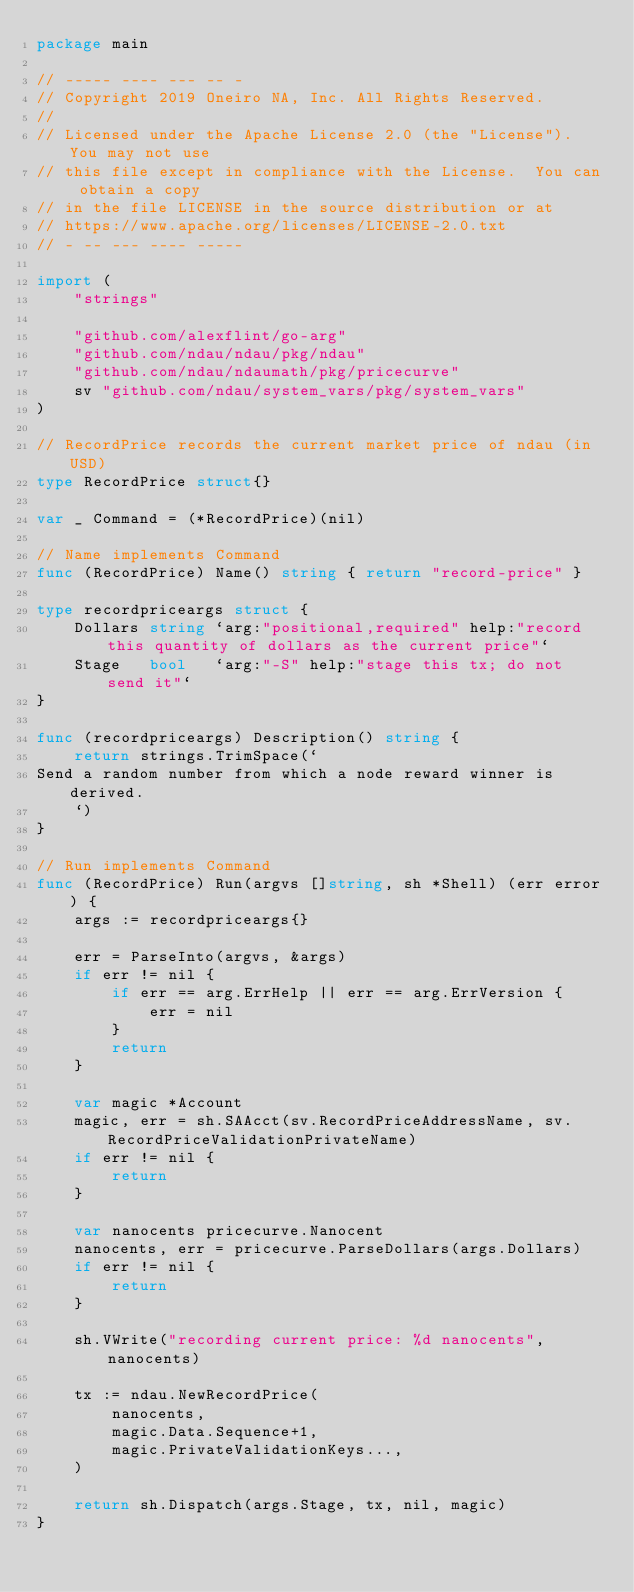Convert code to text. <code><loc_0><loc_0><loc_500><loc_500><_Go_>package main

// ----- ---- --- -- -
// Copyright 2019 Oneiro NA, Inc. All Rights Reserved.
//
// Licensed under the Apache License 2.0 (the "License").  You may not use
// this file except in compliance with the License.  You can obtain a copy
// in the file LICENSE in the source distribution or at
// https://www.apache.org/licenses/LICENSE-2.0.txt
// - -- --- ---- -----

import (
	"strings"

	"github.com/alexflint/go-arg"
	"github.com/ndau/ndau/pkg/ndau"
	"github.com/ndau/ndaumath/pkg/pricecurve"
	sv "github.com/ndau/system_vars/pkg/system_vars"
)

// RecordPrice records the current market price of ndau (in USD)
type RecordPrice struct{}

var _ Command = (*RecordPrice)(nil)

// Name implements Command
func (RecordPrice) Name() string { return "record-price" }

type recordpriceargs struct {
	Dollars string `arg:"positional,required" help:"record this quantity of dollars as the current price"`
	Stage   bool   `arg:"-S" help:"stage this tx; do not send it"`
}

func (recordpriceargs) Description() string {
	return strings.TrimSpace(`
Send a random number from which a node reward winner is derived.
	`)
}

// Run implements Command
func (RecordPrice) Run(argvs []string, sh *Shell) (err error) {
	args := recordpriceargs{}

	err = ParseInto(argvs, &args)
	if err != nil {
		if err == arg.ErrHelp || err == arg.ErrVersion {
			err = nil
		}
		return
	}

	var magic *Account
	magic, err = sh.SAAcct(sv.RecordPriceAddressName, sv.RecordPriceValidationPrivateName)
	if err != nil {
		return
	}

	var nanocents pricecurve.Nanocent
	nanocents, err = pricecurve.ParseDollars(args.Dollars)
	if err != nil {
		return
	}

	sh.VWrite("recording current price: %d nanocents", nanocents)

	tx := ndau.NewRecordPrice(
		nanocents,
		magic.Data.Sequence+1,
		magic.PrivateValidationKeys...,
	)

	return sh.Dispatch(args.Stage, tx, nil, magic)
}
</code> 